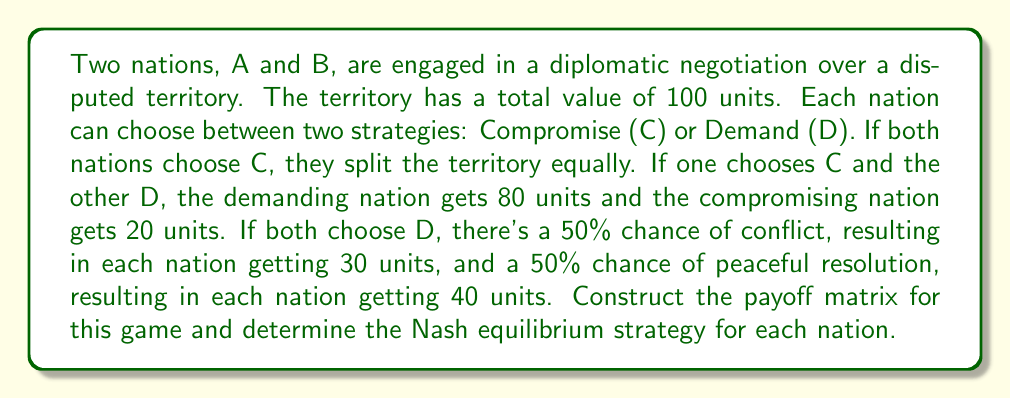Could you help me with this problem? Let's approach this step-by-step:

1) First, we need to construct the payoff matrix. The payoffs for each combination of strategies are as follows:

   - (C,C): Both nations get 50 units each
   - (C,D) or (D,C): The nation choosing D gets 80, the nation choosing C gets 20
   - (D,D): Each nation has an expected payoff of 0.5(30) + 0.5(40) = 35 units

2) The payoff matrix looks like this:

$$
\begin{array}{c|c|c}
 & \text{B: C} & \text{B: D} \\
\hline
\text{A: C} & (50,50) & (20,80) \\
\hline
\text{A: D} & (80,20) & (35,35)
\end{array}
$$

3) To find the Nash equilibrium, we need to check if any player has an incentive to unilaterally deviate from each strategy profile:

   - (C,C): B can deviate to D and get 80 instead of 50
   - (C,D): A can deviate to D and get 35 instead of 20
   - (D,C): B can deviate to D and get 35 instead of 20
   - (D,D): Neither A nor B can improve by deviating

4) Therefore, (D,D) is the only Nash equilibrium in this game.

5) This result demonstrates the "Prisoner's Dilemma" nature of the negotiation. Although both nations would be better off if they both compromised (50 > 35), the dominant strategy for each nation is to Demand, leading to a sub-optimal outcome for both.
Answer: The Nash equilibrium strategy for both nations is to Demand (D,D), resulting in an expected payoff of 35 units for each nation. 